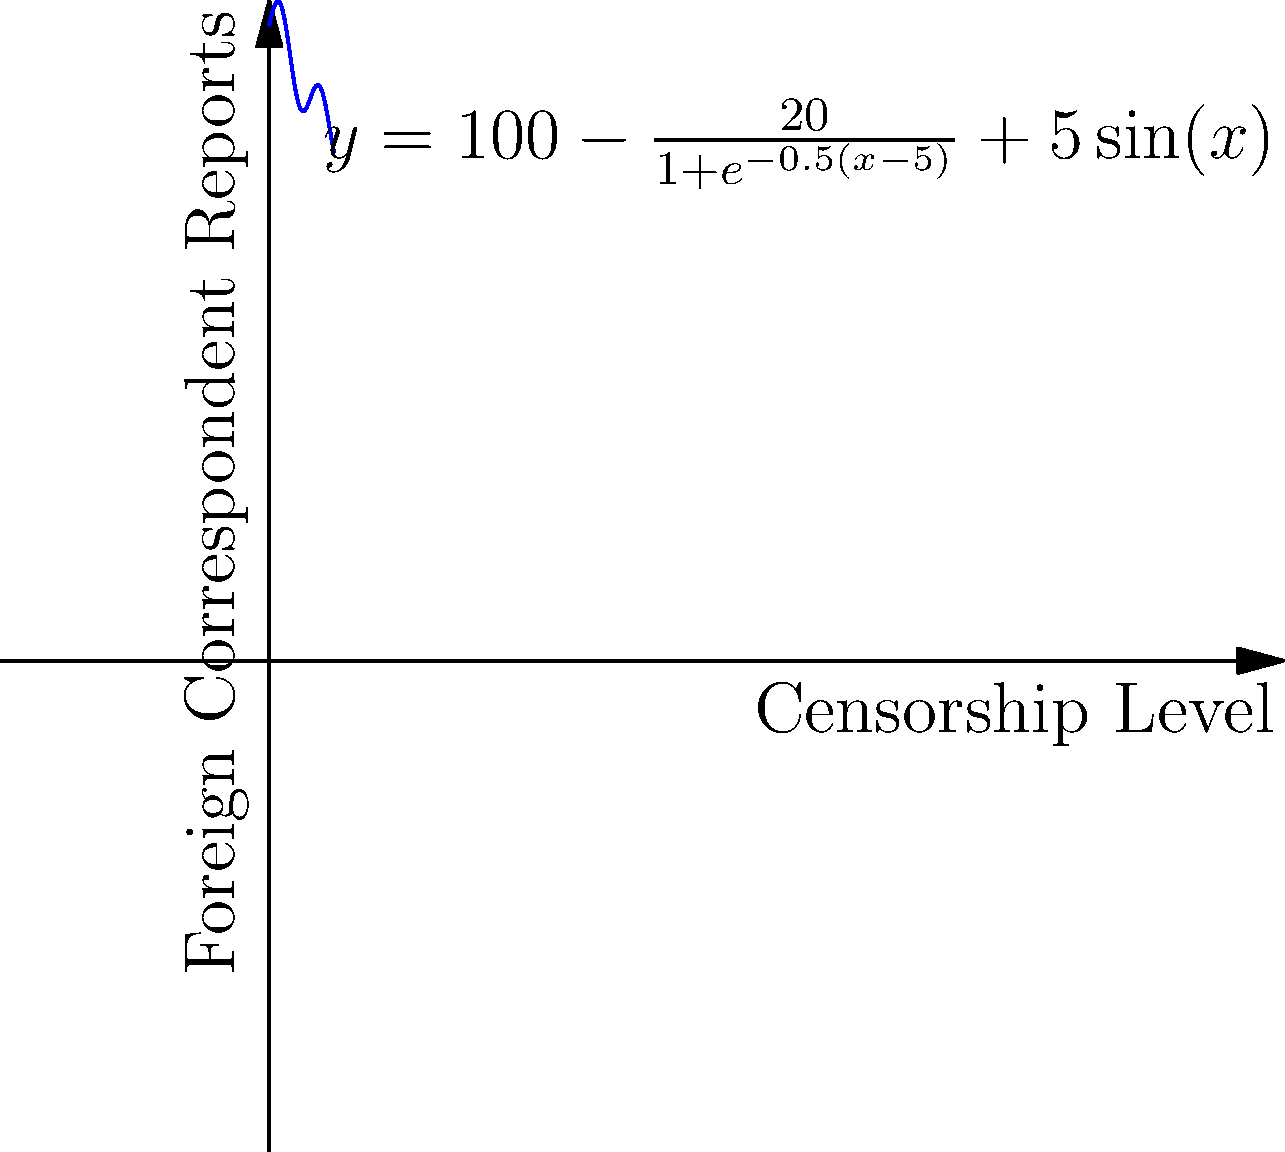The graph above represents the relationship between censorship levels (x-axis) and the number of foreign correspondent reports (y-axis) during the Spanish Civil War. The function is given by $y = 100 - \frac{20}{1+e^{-0.5(x-5)}} + 5\sin(x)$. What is the horizontal asymptote of this function as censorship levels approach infinity, and what does this imply about foreign correspondence in extremely high censorship conditions? To find the horizontal asymptote, we need to analyze the behavior of the function as x approaches infinity:

1. The constant term 100 remains unchanged as x approaches infinity.

2. The term $\frac{20}{1+e^{-0.5(x-5)}}$ approaches 20 as x approaches infinity because $e^{-0.5(x-5)}$ approaches 0, making the denominator approach 1.

3. The term $5\sin(x)$ oscillates between -5 and 5 as x approaches infinity, but does not affect the overall limit.

4. Therefore, as x approaches infinity:
   $\lim_{x \to \infty} (100 - \frac{20}{1+e^{-0.5(x-5)}} + 5\sin(x)) = 100 - 20 + 0 = 80$

5. The horizontal asymptote is y = 80.

This implies that under extremely high censorship conditions, the number of foreign correspondent reports would stabilize around 80, suggesting that some level of reporting persists even in the most restrictive environments, possibly through clandestine methods or external sources.
Answer: Horizontal asymptote: y = 80; implies persistent reporting even under extreme censorship. 